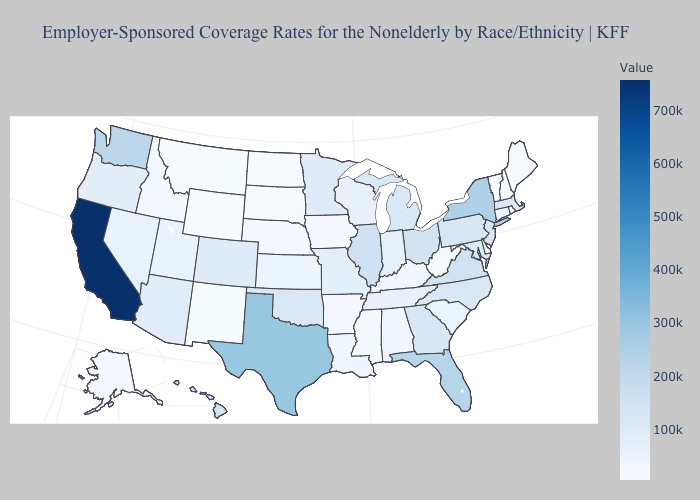Does Oklahoma have the lowest value in the USA?
Keep it brief. No. Does Tennessee have the lowest value in the USA?
Short answer required. No. Which states have the highest value in the USA?
Answer briefly. California. Does Florida have the lowest value in the USA?
Answer briefly. No. Does Utah have the highest value in the USA?
Answer briefly. No. Does Montana have a lower value than Pennsylvania?
Short answer required. Yes. Which states hav the highest value in the Northeast?
Short answer required. New York. Which states have the lowest value in the USA?
Short answer required. Wyoming. 